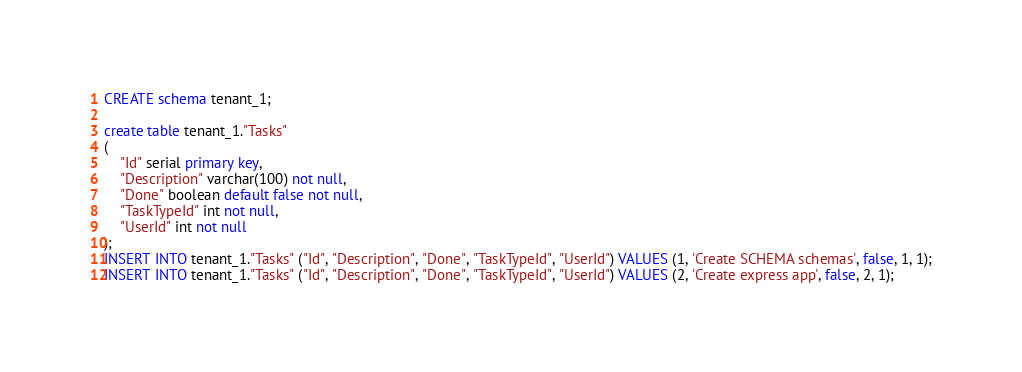Convert code to text. <code><loc_0><loc_0><loc_500><loc_500><_SQL_>CREATE schema tenant_1;

create table tenant_1."Tasks"
(
	"Id" serial primary key,
	"Description" varchar(100) not null,
	"Done" boolean default false not null,
	"TaskTypeId" int not null,
	"UserId" int not null
);
INSERT INTO tenant_1."Tasks" ("Id", "Description", "Done", "TaskTypeId", "UserId") VALUES (1, 'Create SCHEMA schemas', false, 1, 1);
INSERT INTO tenant_1."Tasks" ("Id", "Description", "Done", "TaskTypeId", "UserId") VALUES (2, 'Create express app', false, 2, 1);
</code> 